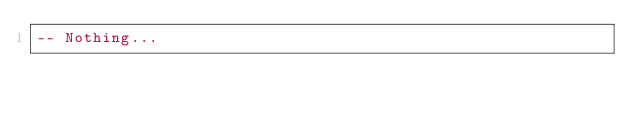Convert code to text. <code><loc_0><loc_0><loc_500><loc_500><_SQL_>-- Nothing...

</code> 